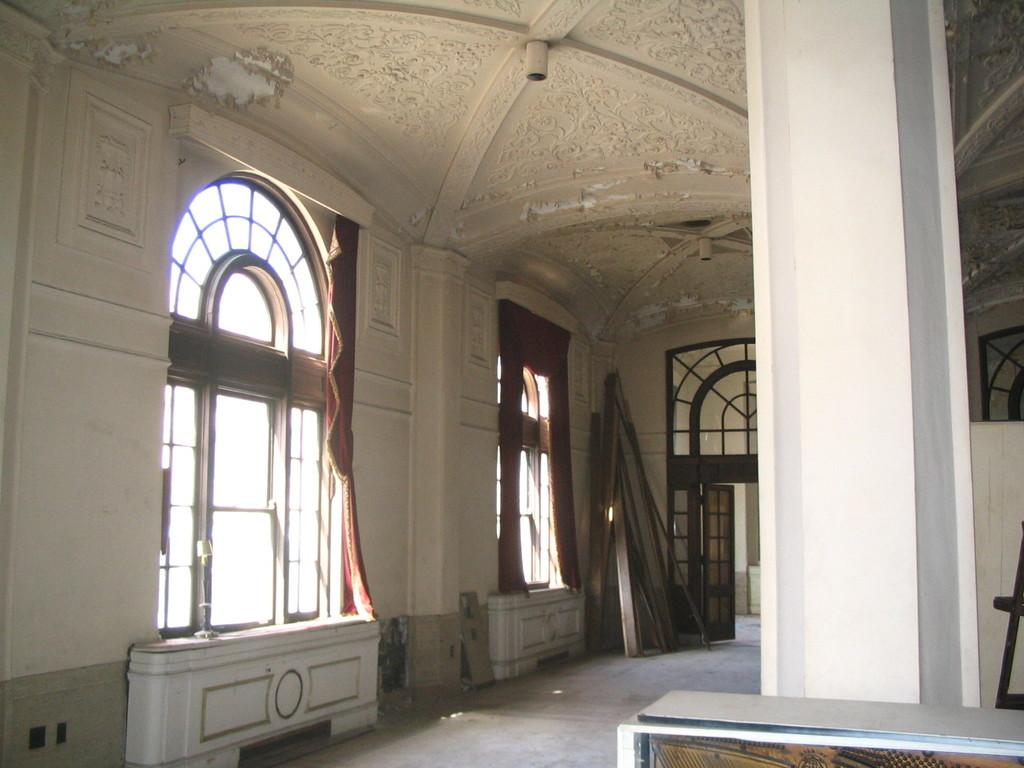What type of view is shown in the image? The image is an inside view of a building. Can you describe any specific features of the building? There are wooden sticks at the corner of the building. What type of rice is being served in the image? There is no rice present in the image; it is an inside view of a building with wooden sticks at the corner. Can you tell me how many chairs are visible in the image? There is no mention of chairs in the provided facts, so it cannot be determined how many chairs are visible in the image. 